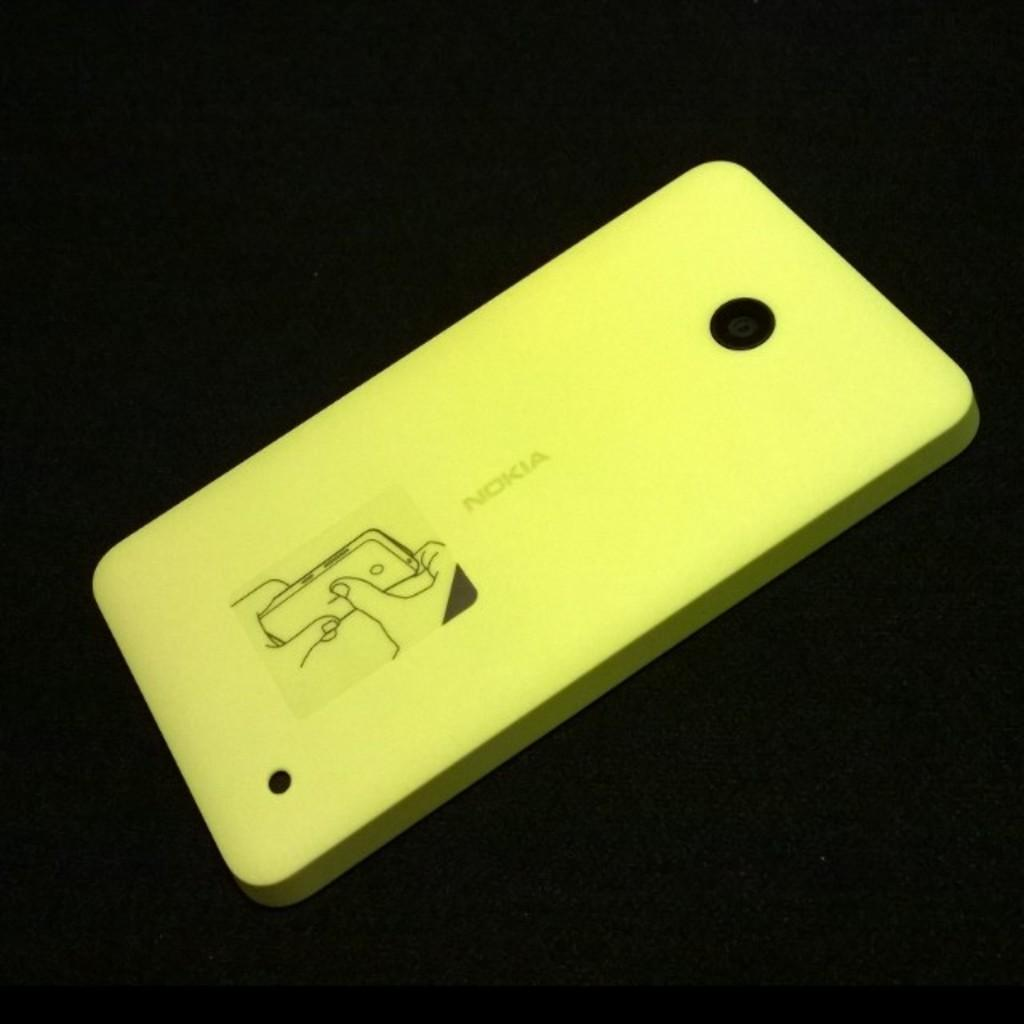What color is the mobile case cover in the image? The mobile case cover is yellow in color. What can be observed about the background of the image? The background of the image is dark. Can you see any grapes on the edge of the ground in the image? There are no grapes or ground present in the image; it only features a yellow mobile case cover against a dark background. 